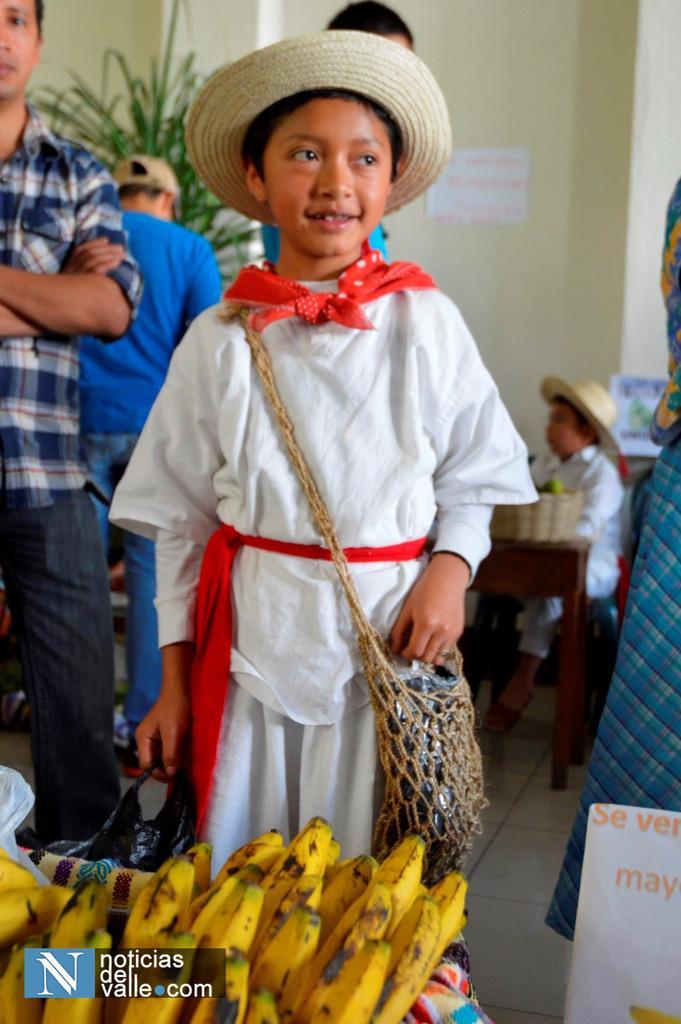In one or two sentences, can you explain what this image depicts? In this image I can see few children and I can see few of them are wearing hats. I can also see he is carrying a bag and here I can see number of yellow colour bananas. I can also see something is written over here and here I can see watermark. I can also see this image is little bit blurry from background. 